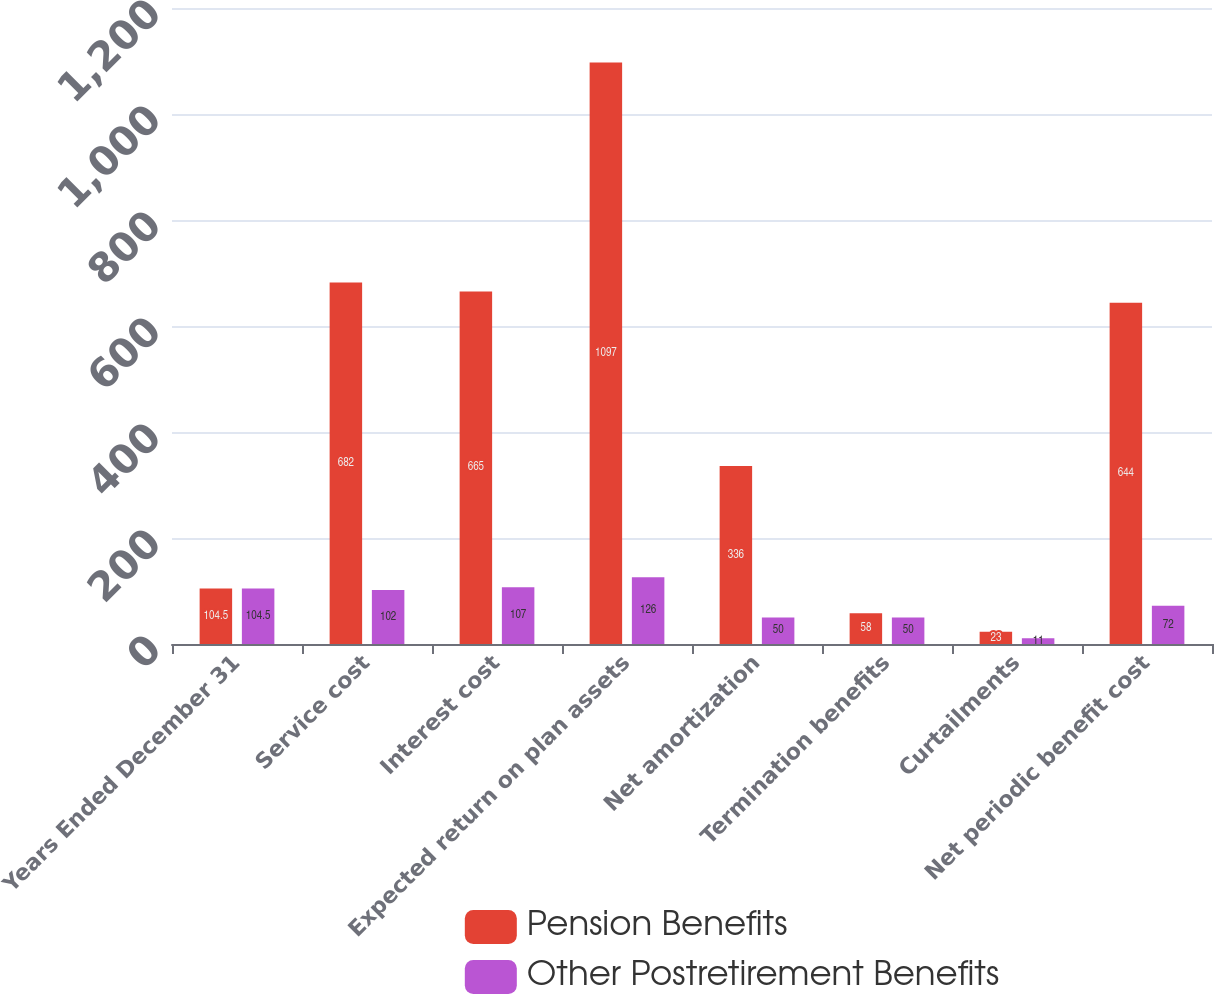Convert chart to OTSL. <chart><loc_0><loc_0><loc_500><loc_500><stacked_bar_chart><ecel><fcel>Years Ended December 31<fcel>Service cost<fcel>Interest cost<fcel>Expected return on plan assets<fcel>Net amortization<fcel>Termination benefits<fcel>Curtailments<fcel>Net periodic benefit cost<nl><fcel>Pension Benefits<fcel>104.5<fcel>682<fcel>665<fcel>1097<fcel>336<fcel>58<fcel>23<fcel>644<nl><fcel>Other Postretirement Benefits<fcel>104.5<fcel>102<fcel>107<fcel>126<fcel>50<fcel>50<fcel>11<fcel>72<nl></chart> 